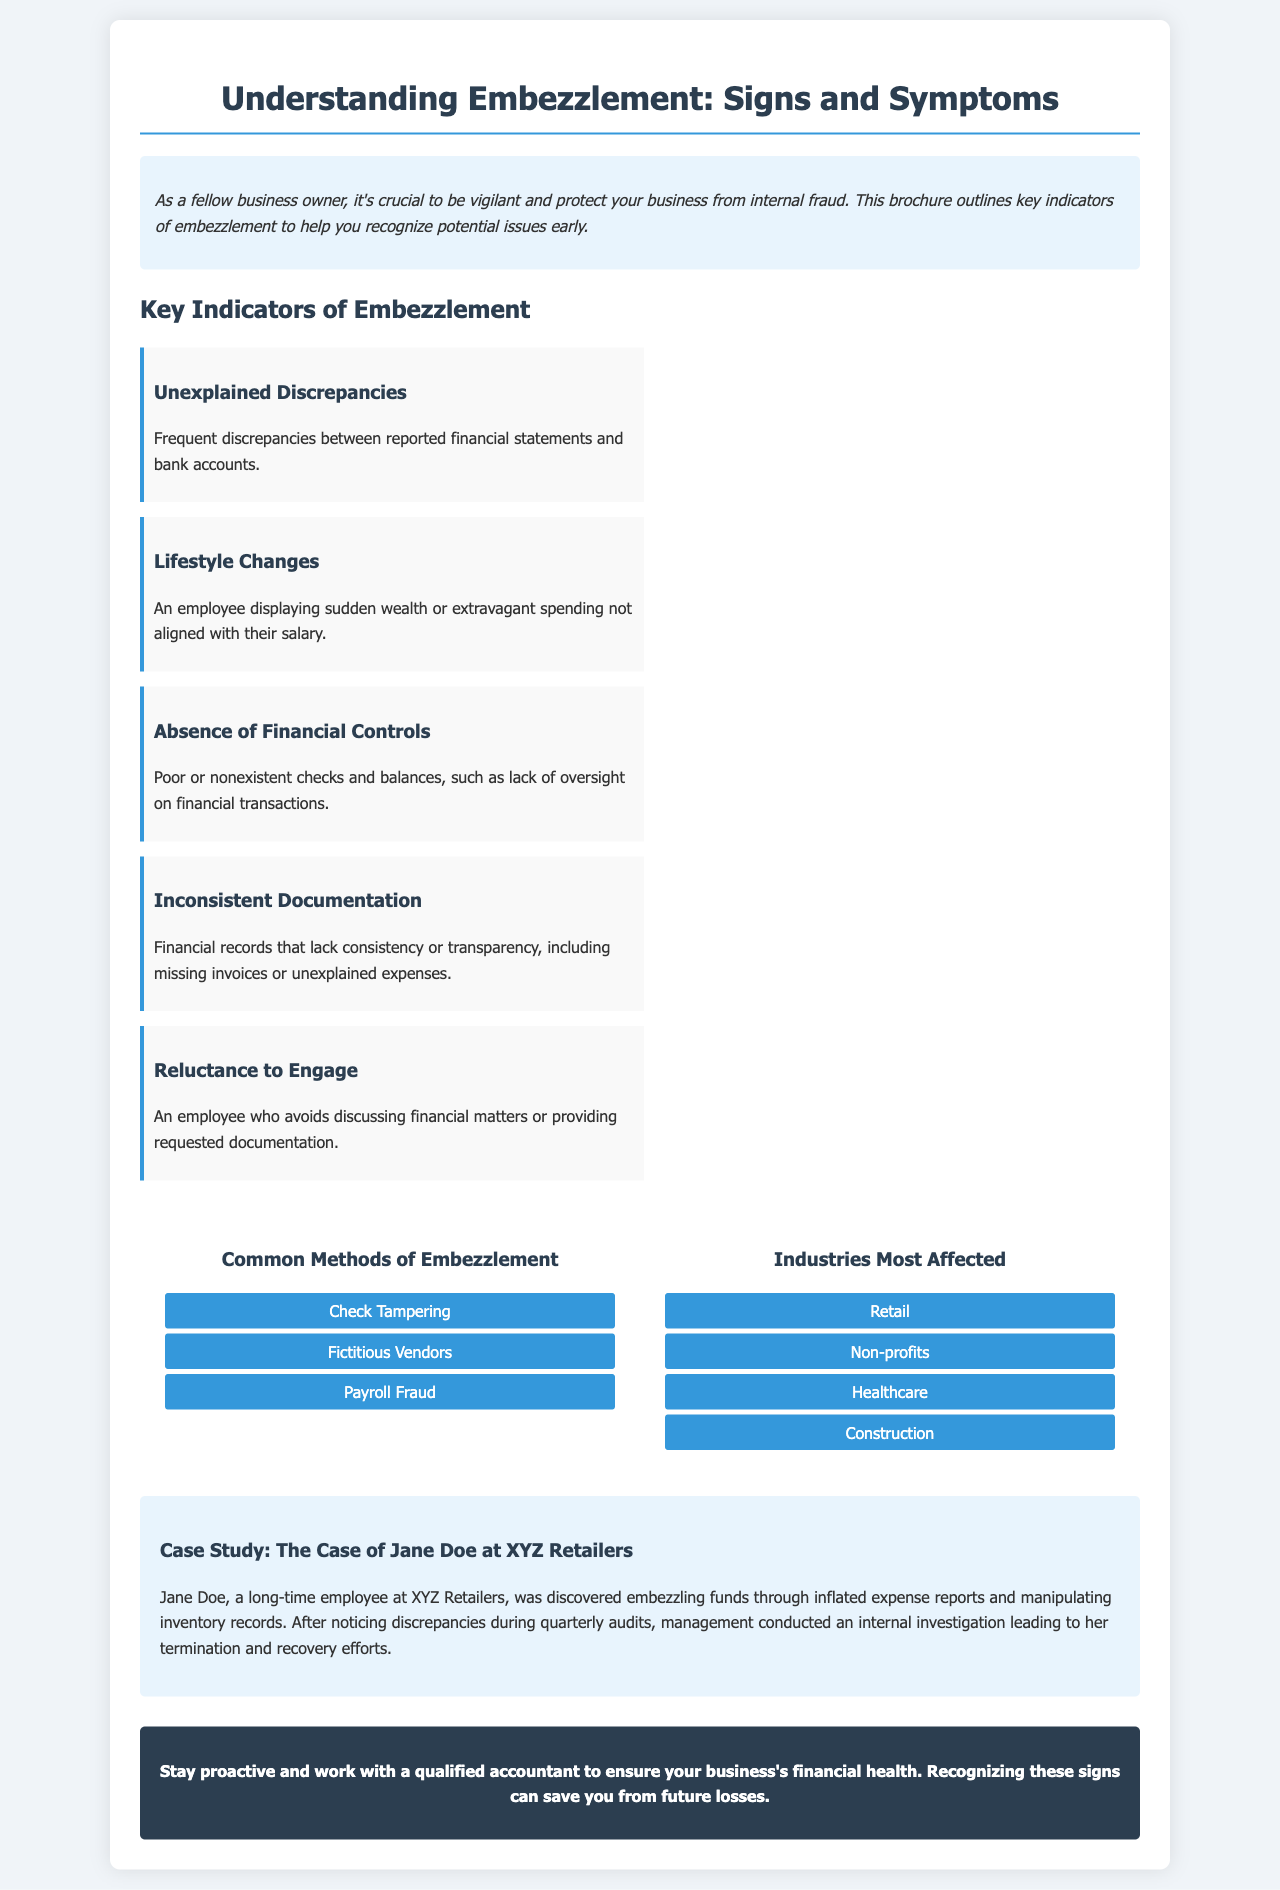what is the title of the brochure? The title of the brochure is presented prominently at the top of the document, indicating its subject matter.
Answer: Understanding Embezzlement: Signs and Symptoms how many key indicators of embezzlement are listed? The document outlines several key indicators of embezzlement in a specific section.
Answer: Five what is one method of embezzlement mentioned in the infographic? The infographic lists common methods of embezzlement, providing examples relevant to the topic.
Answer: Check Tampering which industry is mentioned as most affected by embezzlement? The document highlights specific industries impacted by embezzlement to contextualize the problem.
Answer: Retail who is the case study about? The case study provides a specific example of an embezzlement case to illustrate the content discussed in the brochure.
Answer: Jane Doe what is a sign that an employee may be engaging in embezzlement? The brochure lists various behaviors indicating potential embezzlement activities by employees.
Answer: Lifestyle Changes 